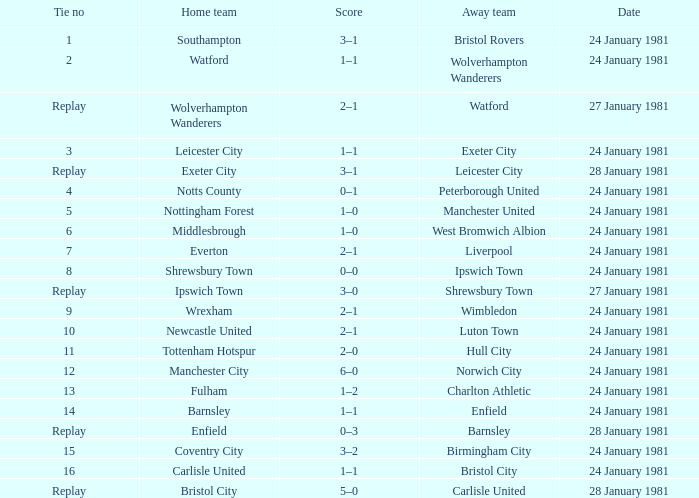What is the score when the tie is 9? 2–1. 